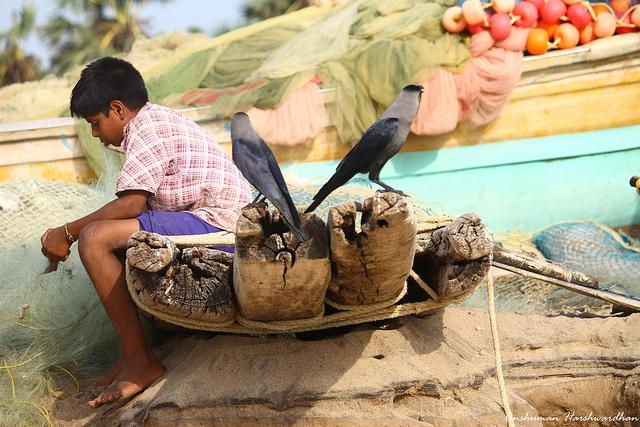What color is the boys hair?
Quick response, please. Black. What are the birds doing?
Write a very short answer. Sitting. Is there a boat in this picture?
Quick response, please. Yes. 